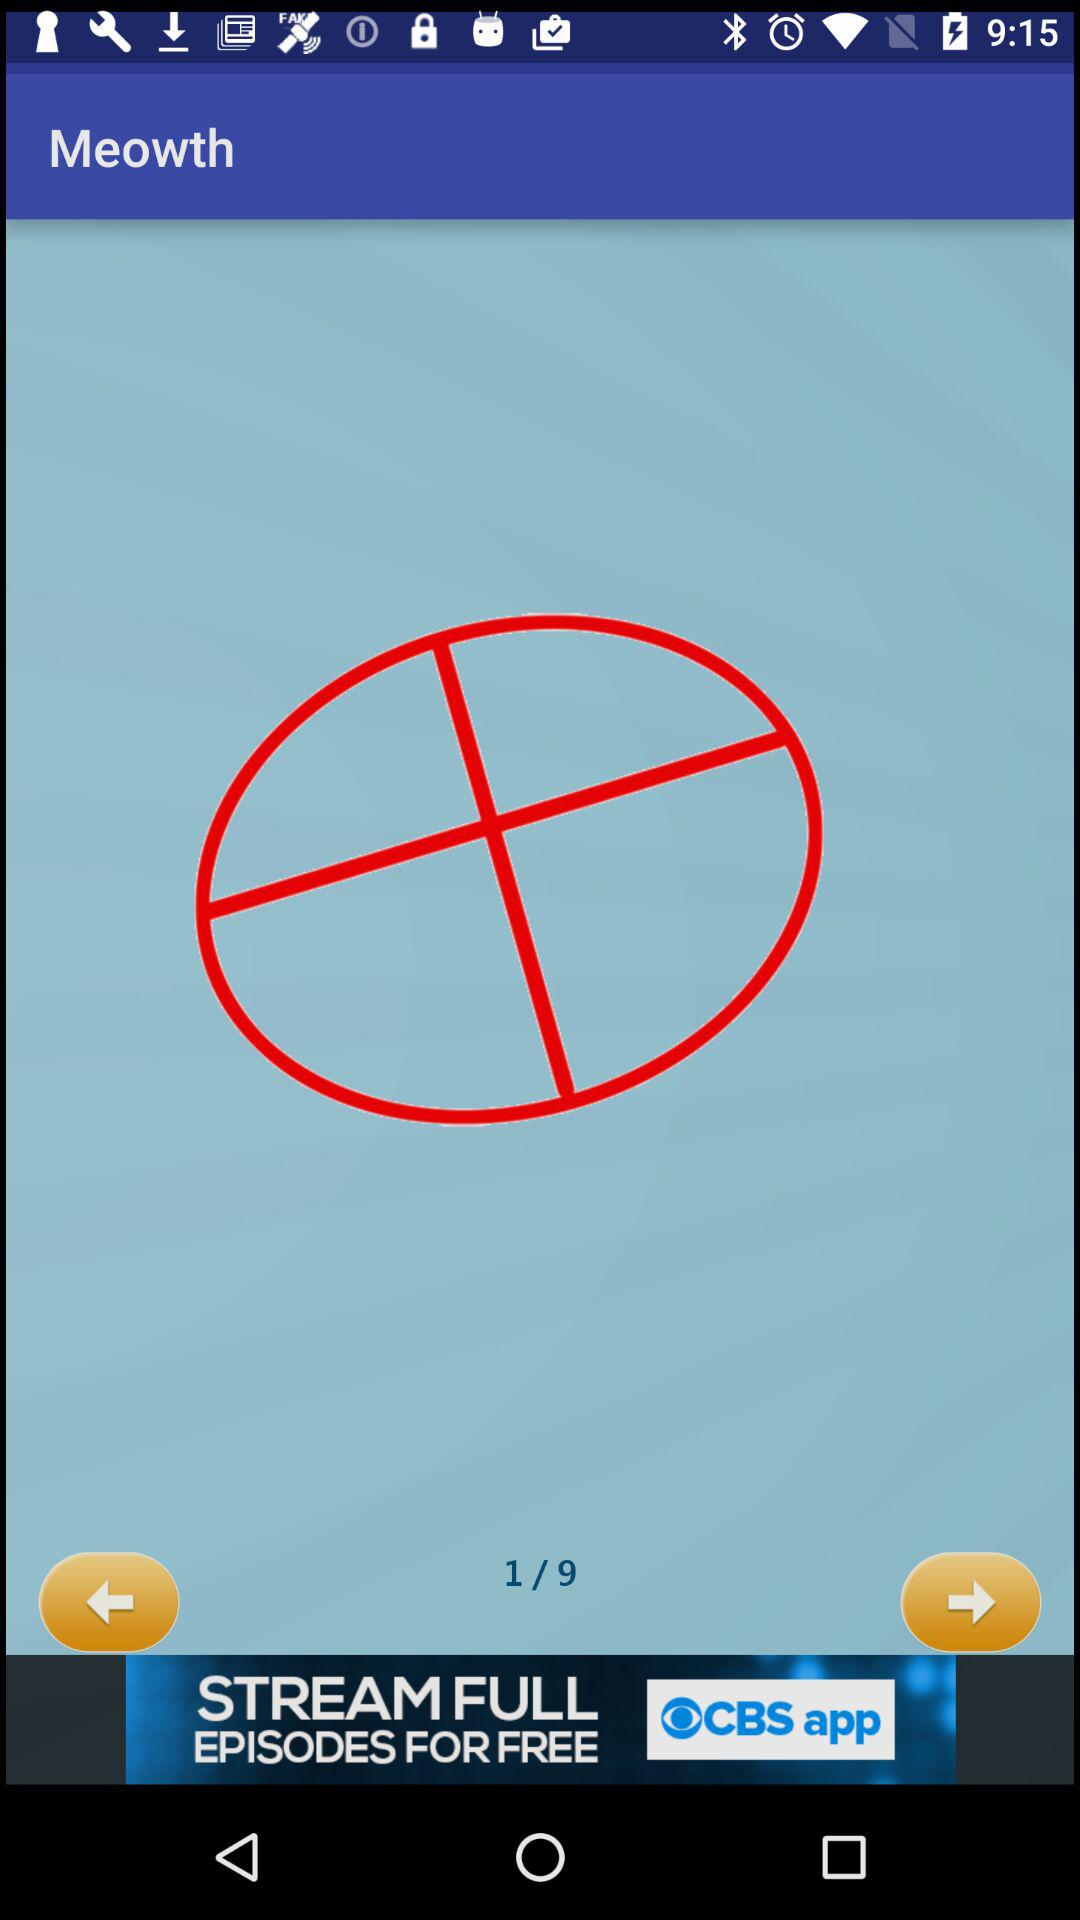What is the total number of pages? The total number of pages is 9. 